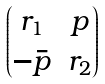Convert formula to latex. <formula><loc_0><loc_0><loc_500><loc_500>\begin{pmatrix} r _ { 1 } & p \\ - \bar { p } & r _ { 2 } \end{pmatrix}</formula> 